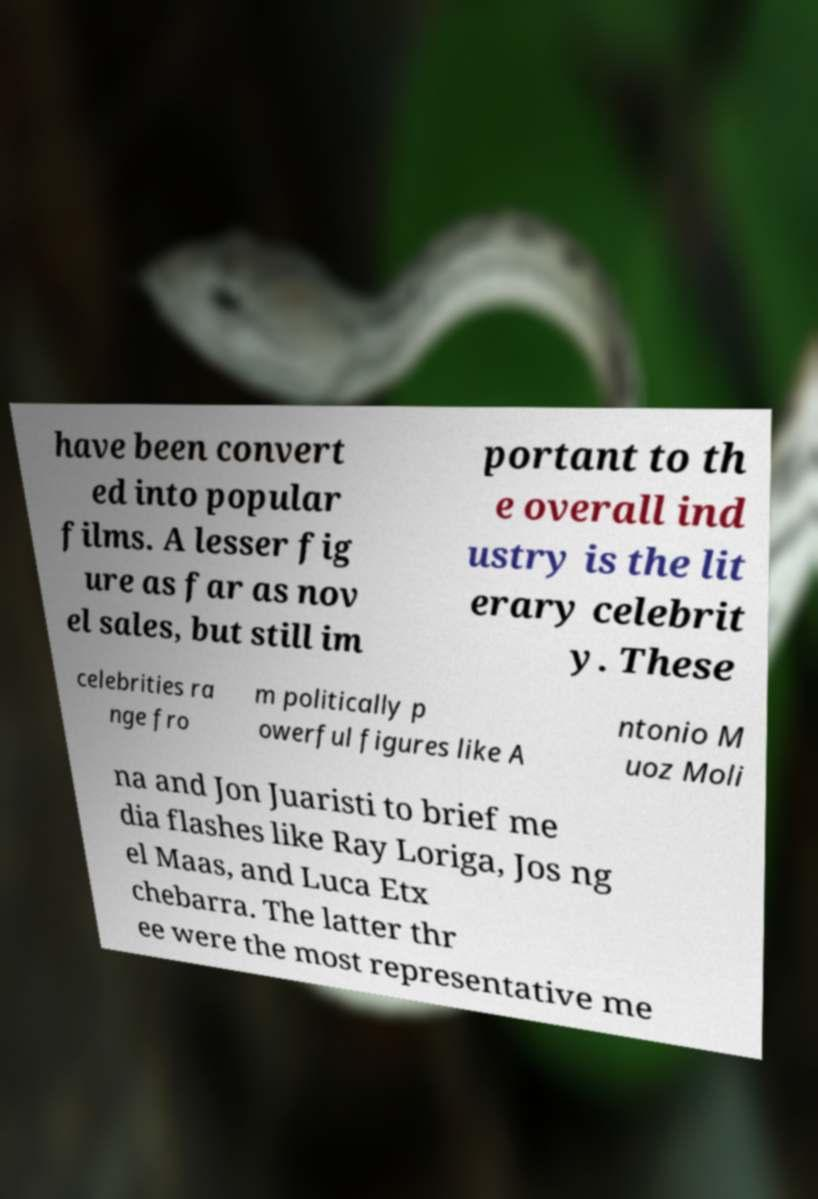There's text embedded in this image that I need extracted. Can you transcribe it verbatim? have been convert ed into popular films. A lesser fig ure as far as nov el sales, but still im portant to th e overall ind ustry is the lit erary celebrit y. These celebrities ra nge fro m politically p owerful figures like A ntonio M uoz Moli na and Jon Juaristi to brief me dia flashes like Ray Loriga, Jos ng el Maas, and Luca Etx chebarra. The latter thr ee were the most representative me 